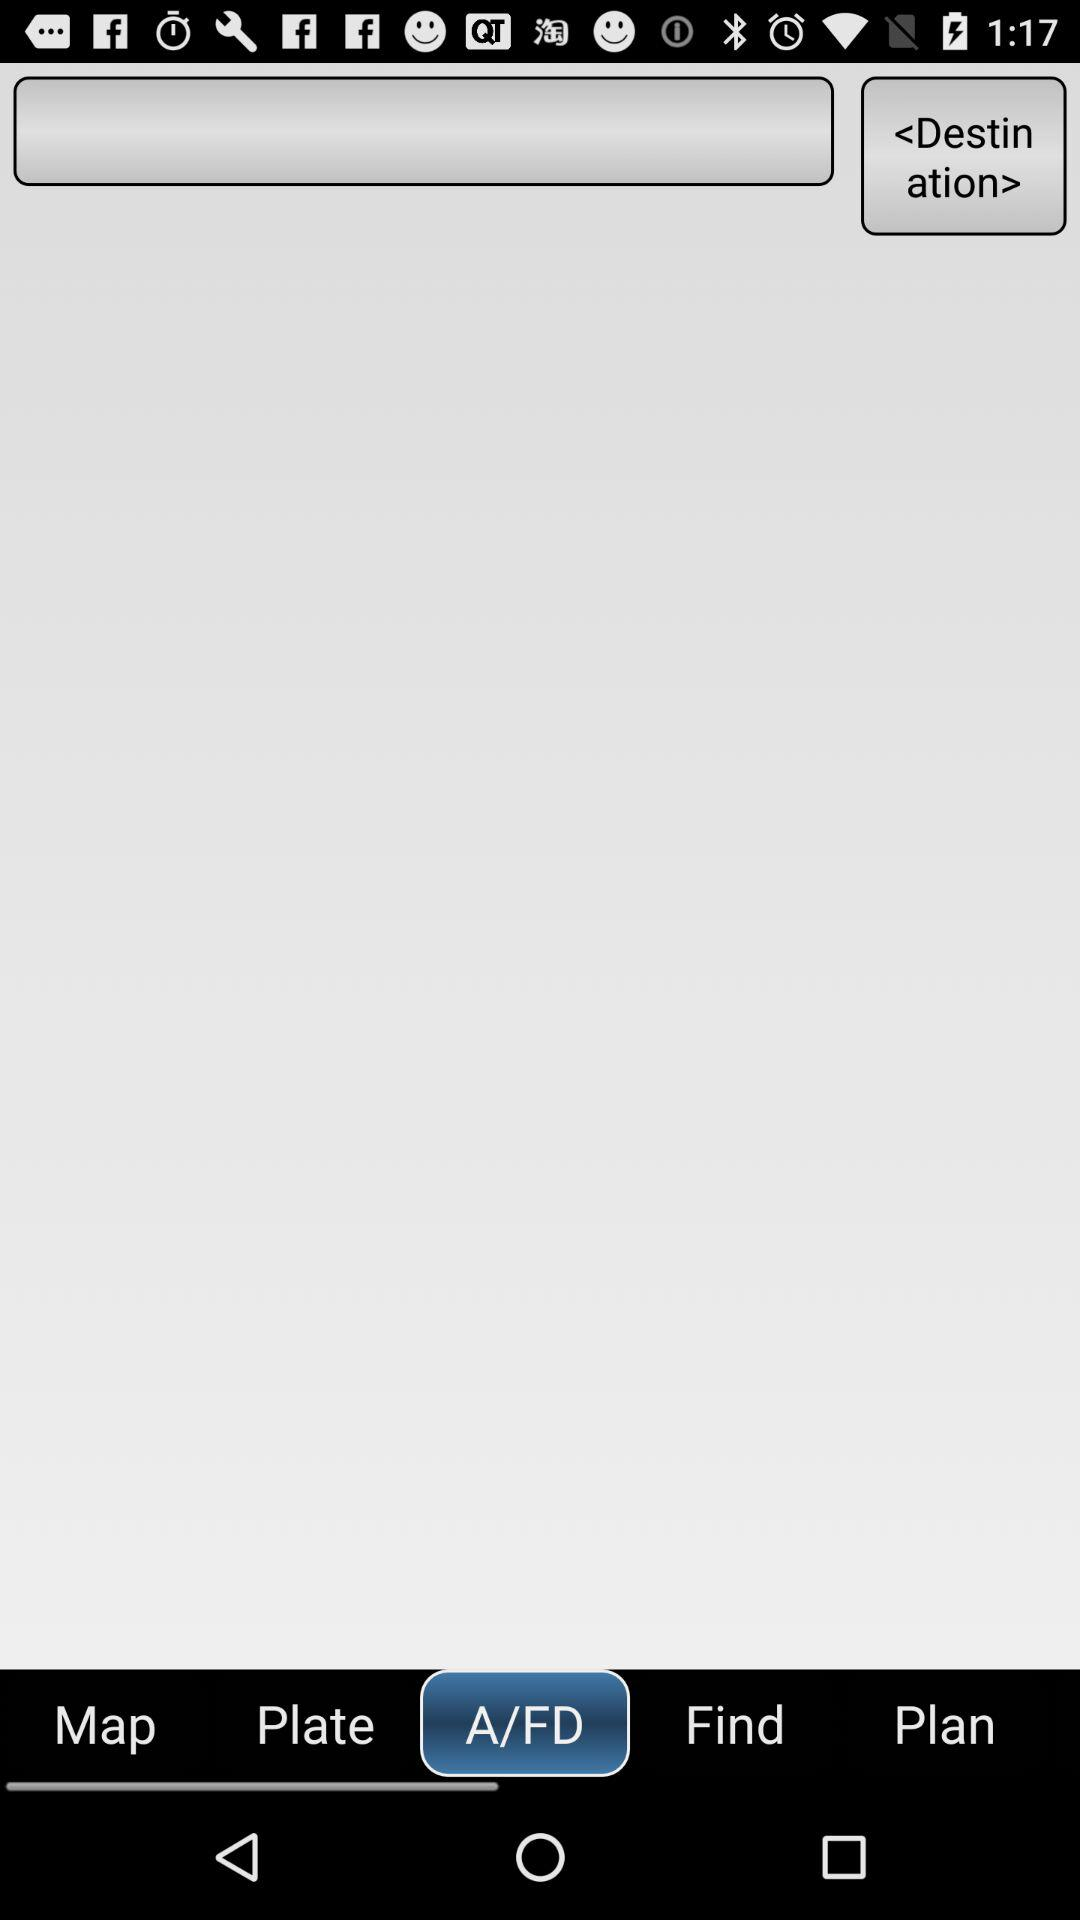Which option is selected? The selected option is "A/FD". 